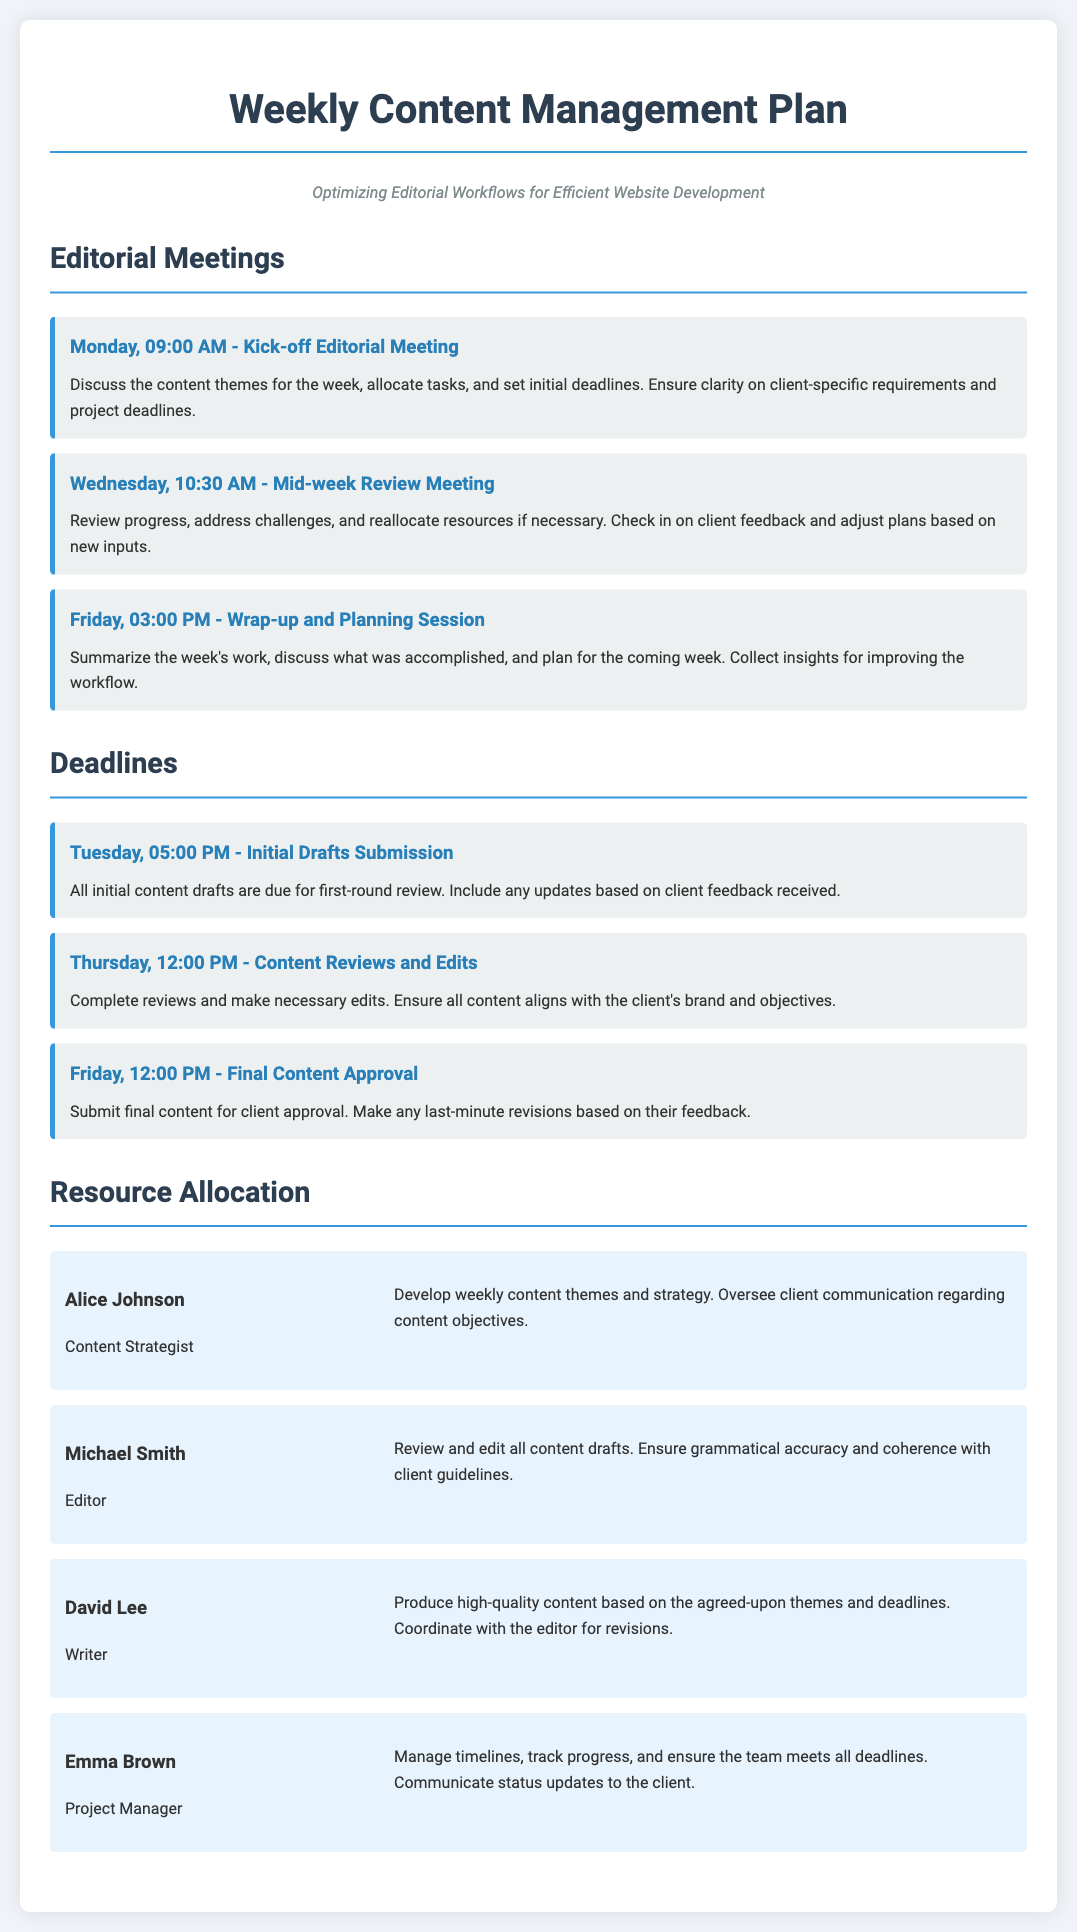What time is the kick-off editorial meeting? The kick-off editorial meeting is scheduled for Monday at 09:00 AM.
Answer: 09:00 AM Who is responsible for content strategy? Alice Johnson is the Content Strategist in charge of developing weekly content themes and strategy.
Answer: Alice Johnson When is the final content approval deadline? The final content approval is due on Friday at 12:00 PM.
Answer: Friday, 12:00 PM How many editorial meetings are scheduled in the week? There are three editorial meetings listed in the document.
Answer: Three What task does Michael Smith perform? Michael Smith is responsible for reviewing and editing all content drafts to ensure grammatical accuracy and coherence.
Answer: Editor What is the purpose of the mid-week review meeting? The mid-week review meeting is for reviewing progress, addressing challenges, and reallocating resources if necessary.
Answer: Review progress What is Emma Brown's role in the team? Emma Brown serves as the Project Manager, overseeing timelines and progress tracking.
Answer: Project Manager What day are the initial drafts due for submission? The initial drafts submission deadline is set for Tuesday at 05:00 PM.
Answer: Tuesday, 05:00 PM How many resources are allocated for content management? There are four resources listed in the document for content management.
Answer: Four 